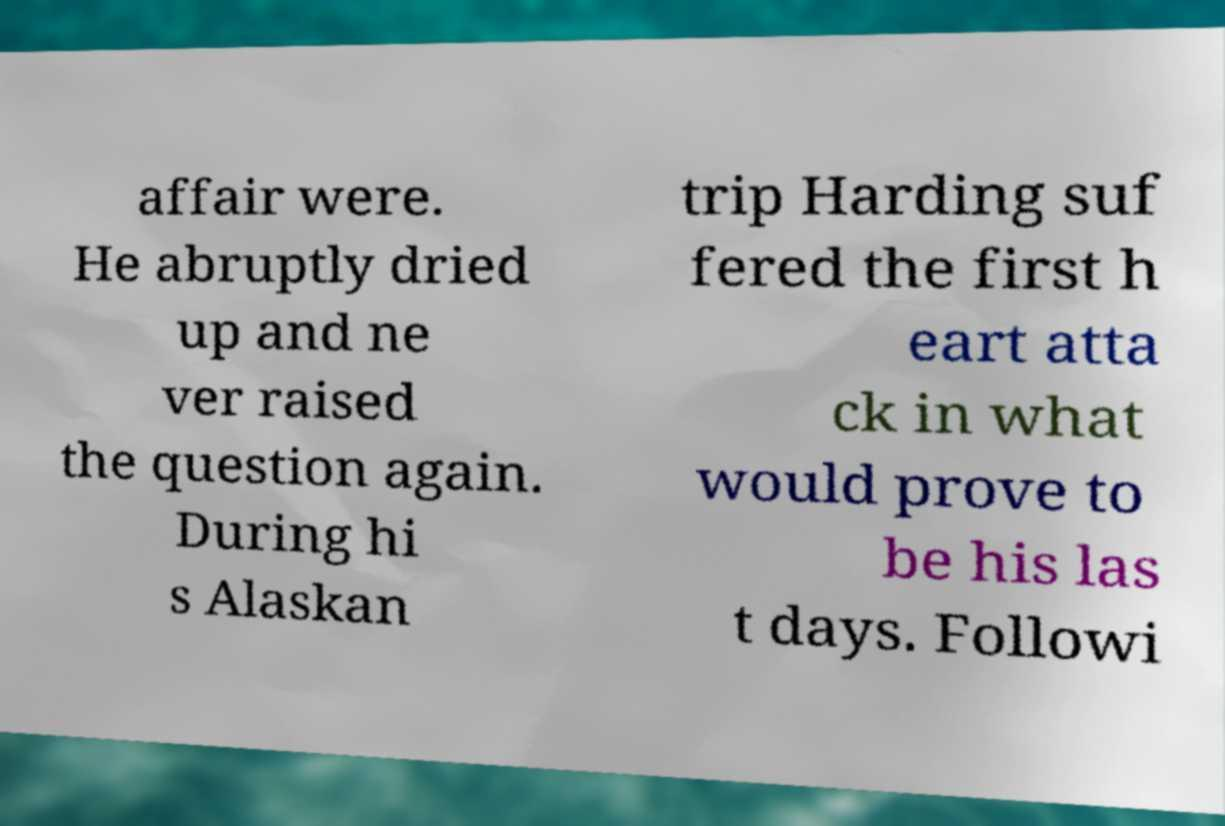Can you read and provide the text displayed in the image?This photo seems to have some interesting text. Can you extract and type it out for me? affair were. He abruptly dried up and ne ver raised the question again. During hi s Alaskan trip Harding suf fered the first h eart atta ck in what would prove to be his las t days. Followi 